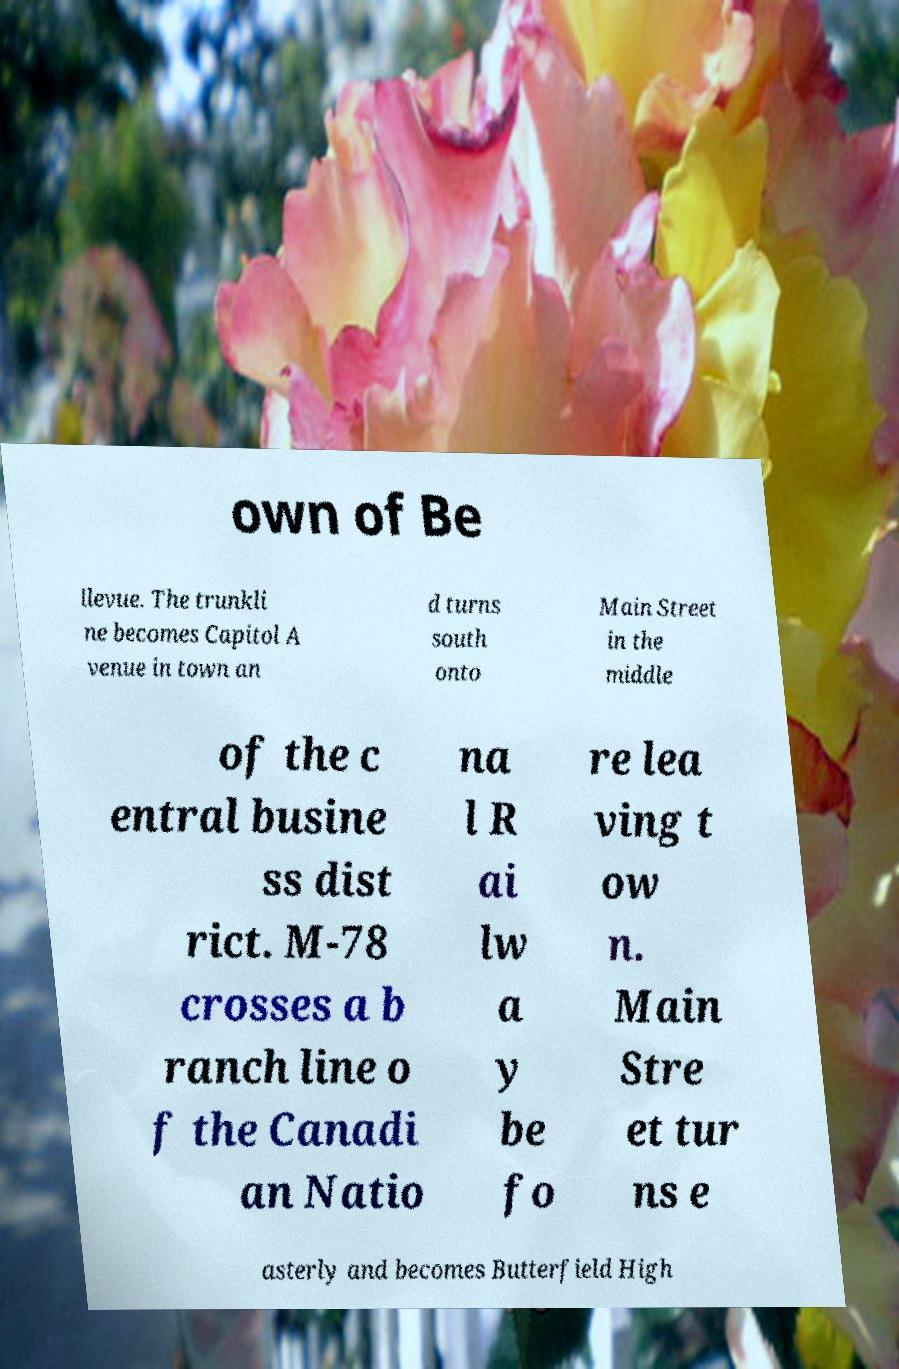What messages or text are displayed in this image? I need them in a readable, typed format. own of Be llevue. The trunkli ne becomes Capitol A venue in town an d turns south onto Main Street in the middle of the c entral busine ss dist rict. M-78 crosses a b ranch line o f the Canadi an Natio na l R ai lw a y be fo re lea ving t ow n. Main Stre et tur ns e asterly and becomes Butterfield High 